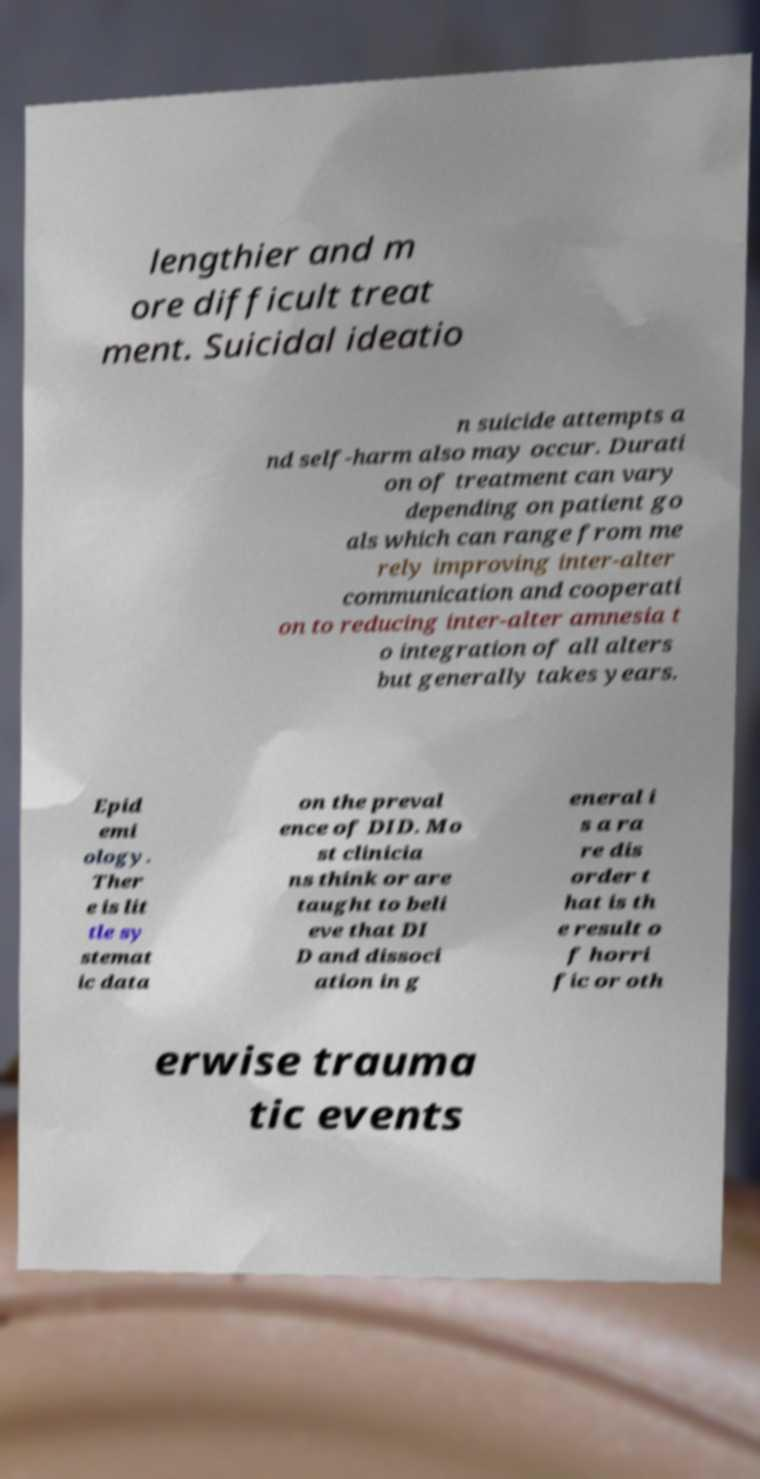Could you assist in decoding the text presented in this image and type it out clearly? lengthier and m ore difficult treat ment. Suicidal ideatio n suicide attempts a nd self-harm also may occur. Durati on of treatment can vary depending on patient go als which can range from me rely improving inter-alter communication and cooperati on to reducing inter-alter amnesia t o integration of all alters but generally takes years. Epid emi ology. Ther e is lit tle sy stemat ic data on the preval ence of DID. Mo st clinicia ns think or are taught to beli eve that DI D and dissoci ation in g eneral i s a ra re dis order t hat is th e result o f horri fic or oth erwise trauma tic events 